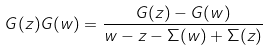<formula> <loc_0><loc_0><loc_500><loc_500>G ( z ) G ( w ) = \frac { G ( z ) - G ( w ) } { w - z - \Sigma ( w ) + \Sigma ( z ) }</formula> 